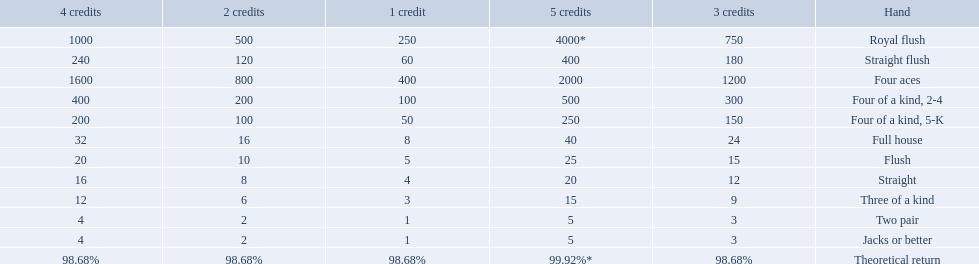Which hand is the third best hand in the card game super aces? Four aces. Which hand is the second best hand? Straight flush. Which hand had is the best hand? Royal flush. 